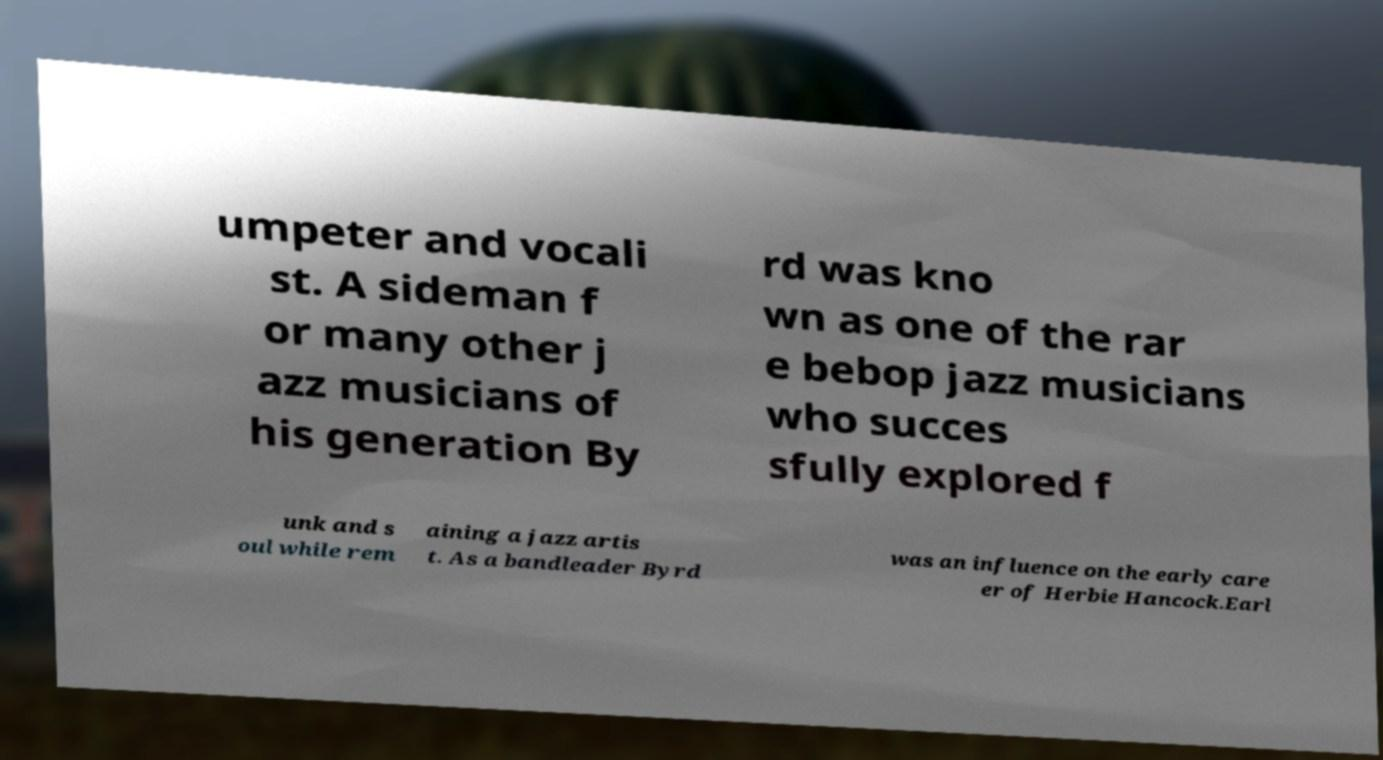I need the written content from this picture converted into text. Can you do that? umpeter and vocali st. A sideman f or many other j azz musicians of his generation By rd was kno wn as one of the rar e bebop jazz musicians who succes sfully explored f unk and s oul while rem aining a jazz artis t. As a bandleader Byrd was an influence on the early care er of Herbie Hancock.Earl 